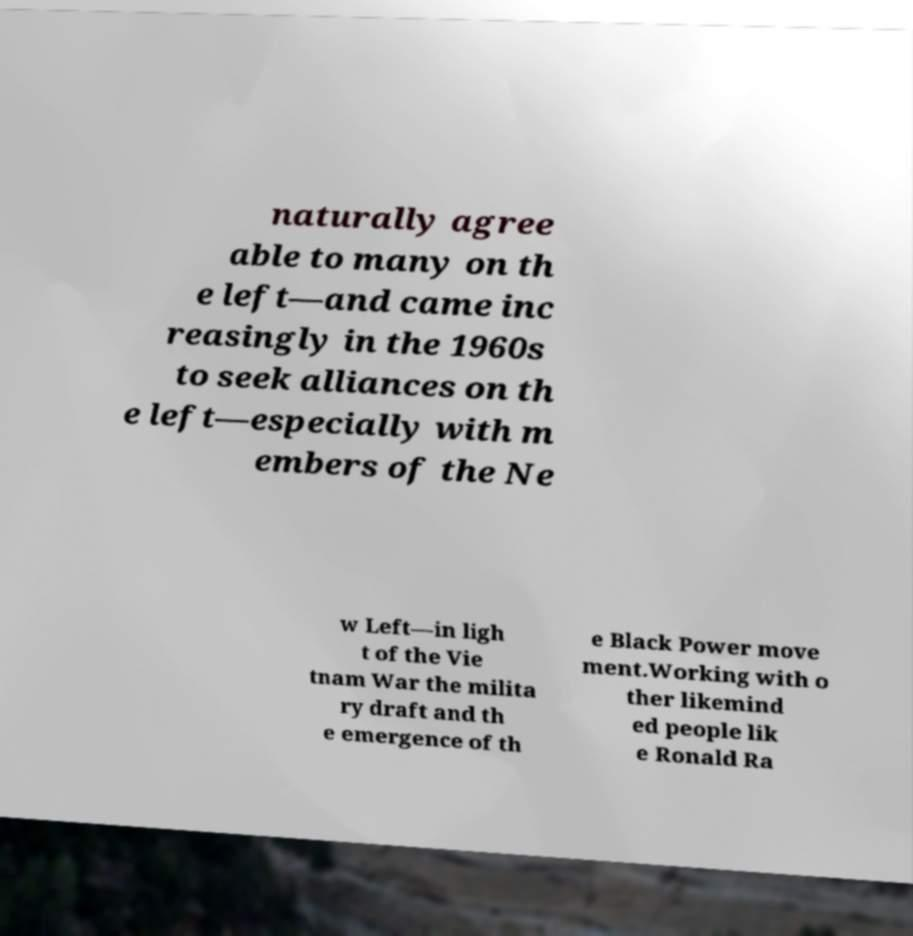Please read and relay the text visible in this image. What does it say? naturally agree able to many on th e left—and came inc reasingly in the 1960s to seek alliances on th e left—especially with m embers of the Ne w Left—in ligh t of the Vie tnam War the milita ry draft and th e emergence of th e Black Power move ment.Working with o ther likemind ed people lik e Ronald Ra 